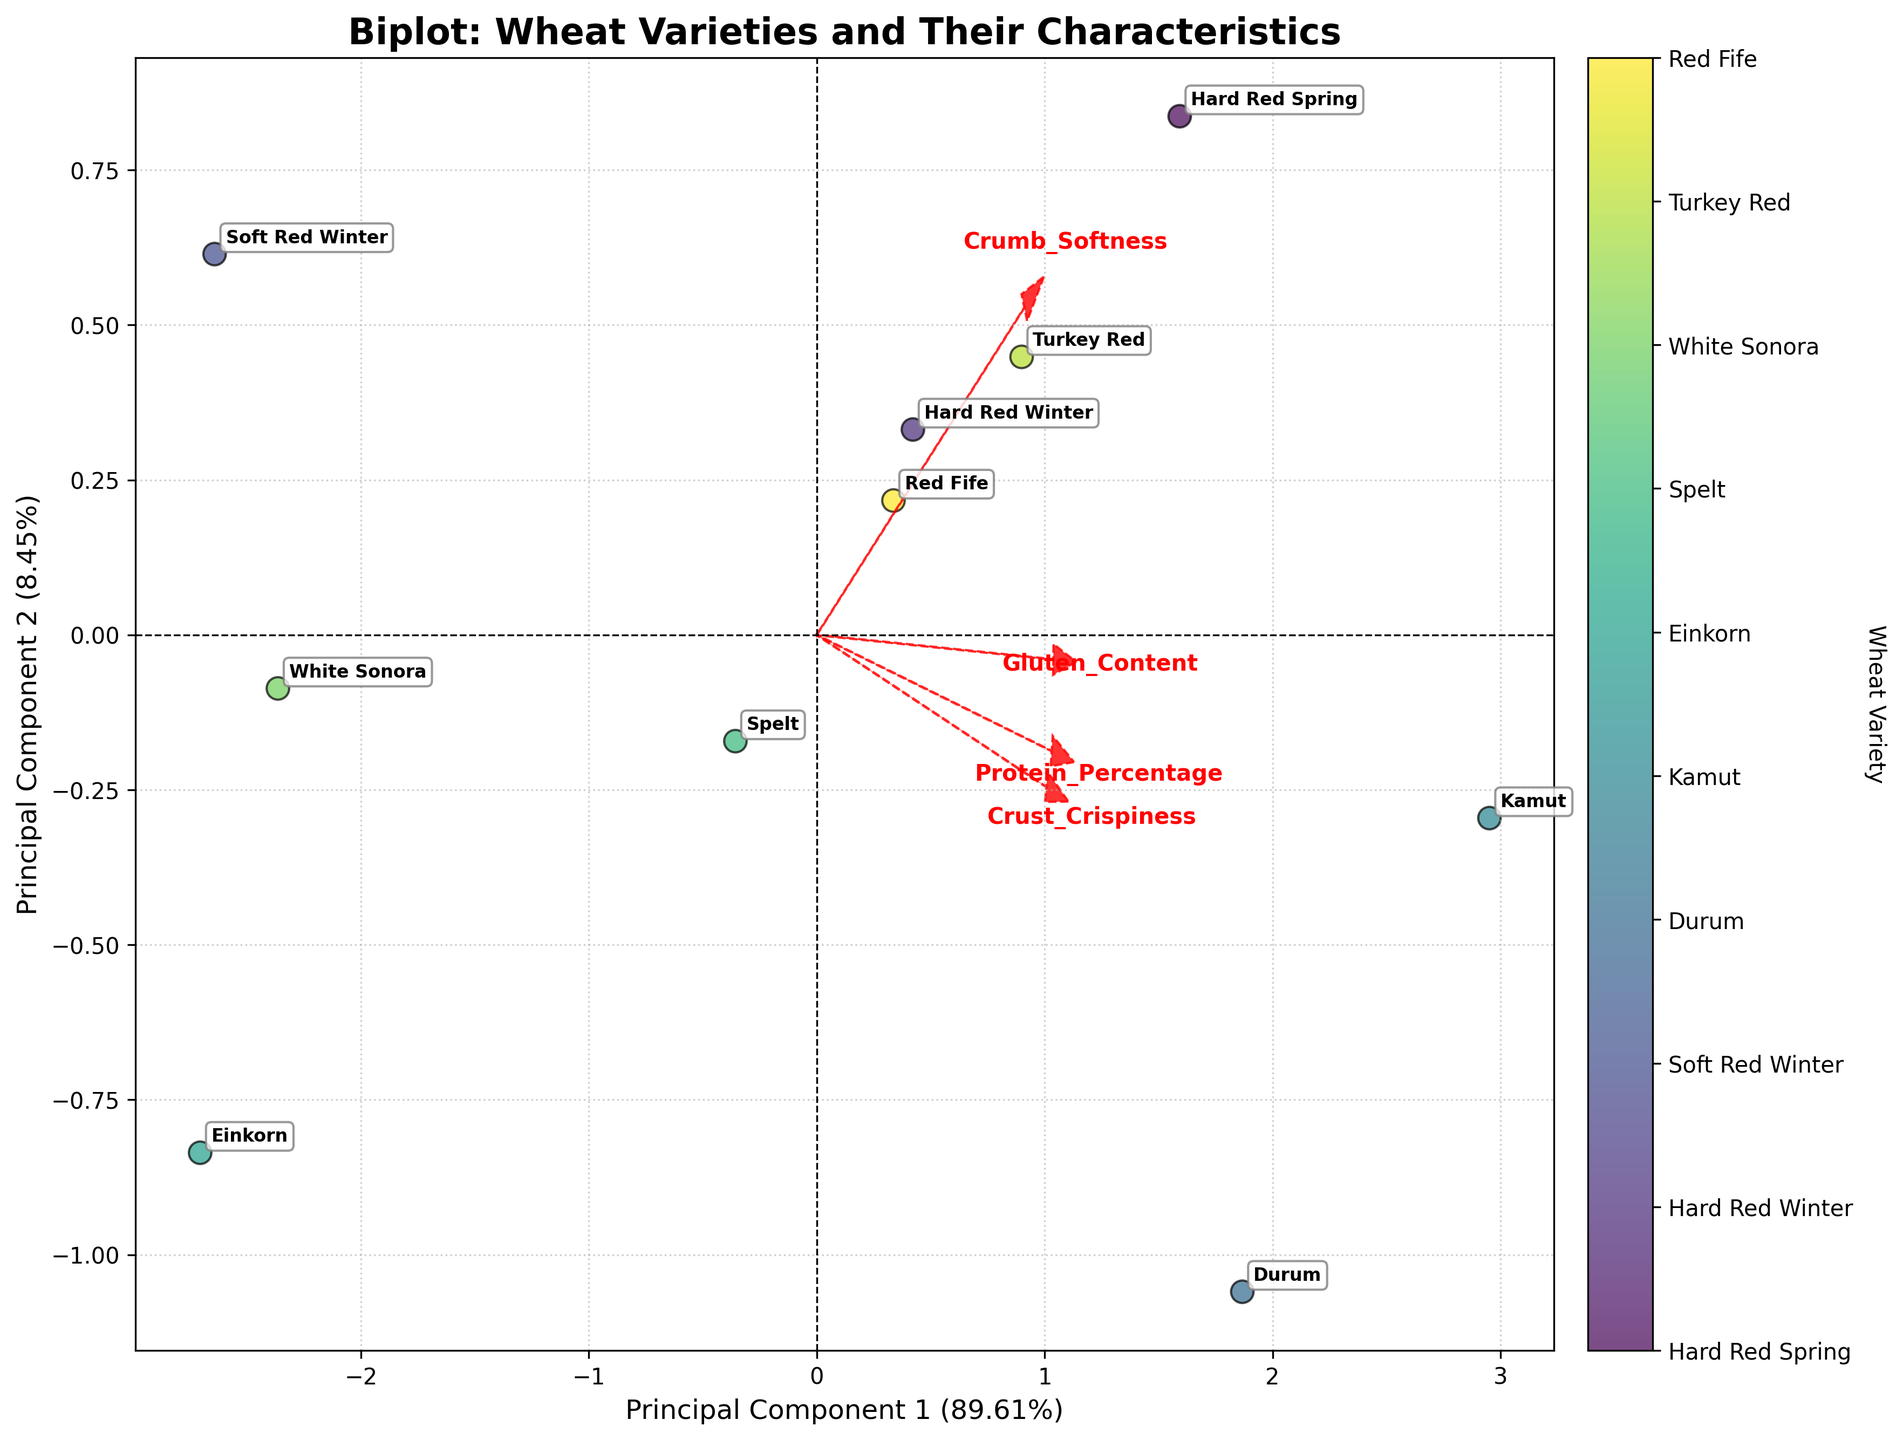How many principal components are used in the biplot? The biplot shows two principal components. The axes are labeled Principal Component 1 and Principal Component 2.
Answer: 2 Which wheat variety has the highest score along Principal Component 1? The variety Kamut is farthest to the right along the x-axis, which represents Principal Component 1.
Answer: Kamut What percentage of variance is explained by Principal Component 1? The x-axis label indicates the variance explained by Principal Component 1 as approximately 53%.
Answer: 53% What feature has the largest loading on Principal Component 2? The Crust Crispiness arrow is the longest along Principal Component 2 (y-axis), indicating it has the largest loading on that component.
Answer: Crust Crispiness Which two features are closest in their loading vectors? Gluten Content and Protein Percentage have loading vectors that are close to each other in direction and length.
Answer: Gluten Content and Protein Percentage Is there a variety that stands out with a combination of high Crumb Softness and Crust Crispiness? The variety labeled Kamut is positioned high along both the Crumb Softness and Crust Crispiness vectors, suggesting it combines high values for these features.
Answer: Kamut Which wheat variety has the most negative score along Principal Component 2? Soft Red Winter is positioned lowest along the y-axis, which represents Principal Component 2.
Answer: Soft Red Winter Compare the positions of Hard Red Spring and White Sonora in relation to Principal Component 1. Hard Red Spring is positioned farther to the right compared to White Sonora along the x-axis (Principal Component 1), indicating its higher score on this component.
Answer: Hard Red Spring What effect does Crumb Softness seem to have based on its loading vector direction? The vector for Crumb Softness indicates that higher values of Crumb Softness are associated with higher scores on Principal Component 2.
Answer: Higher PC2 scores If a bread with high Crust Crispiness is desired, which wheat variety should be preferred? Kamut has the highest loading on the Crust Crispiness vector, indicating it should be preferred for a bread with high crust crispiness.
Answer: Kamut 